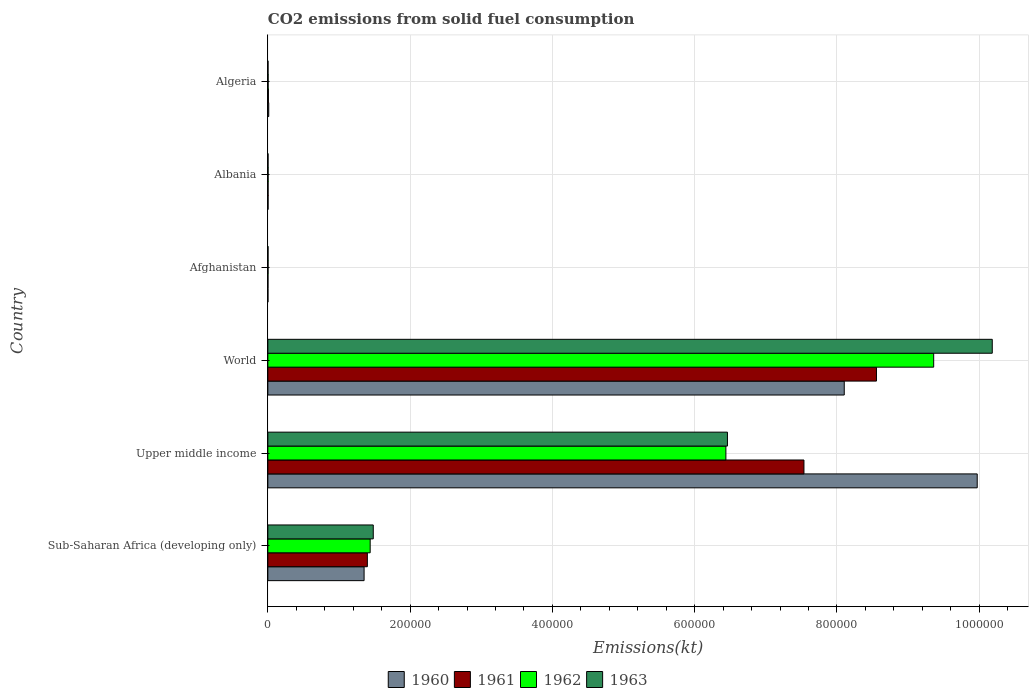How many bars are there on the 5th tick from the bottom?
Provide a succinct answer. 4. What is the label of the 3rd group of bars from the top?
Give a very brief answer. Afghanistan. In how many cases, is the number of bars for a given country not equal to the number of legend labels?
Your response must be concise. 0. What is the amount of CO2 emitted in 1963 in World?
Keep it short and to the point. 1.02e+06. Across all countries, what is the maximum amount of CO2 emitted in 1960?
Your response must be concise. 9.97e+05. Across all countries, what is the minimum amount of CO2 emitted in 1963?
Keep it short and to the point. 253.02. In which country was the amount of CO2 emitted in 1963 maximum?
Provide a succinct answer. World. In which country was the amount of CO2 emitted in 1963 minimum?
Provide a succinct answer. Algeria. What is the total amount of CO2 emitted in 1960 in the graph?
Ensure brevity in your answer.  1.94e+06. What is the difference between the amount of CO2 emitted in 1963 in Albania and that in Sub-Saharan Africa (developing only)?
Give a very brief answer. -1.48e+05. What is the difference between the amount of CO2 emitted in 1962 in World and the amount of CO2 emitted in 1961 in Upper middle income?
Keep it short and to the point. 1.82e+05. What is the average amount of CO2 emitted in 1963 per country?
Provide a short and direct response. 3.02e+05. What is the difference between the amount of CO2 emitted in 1962 and amount of CO2 emitted in 1960 in Albania?
Give a very brief answer. 36.67. In how many countries, is the amount of CO2 emitted in 1962 greater than 720000 kt?
Provide a succinct answer. 1. What is the ratio of the amount of CO2 emitted in 1960 in Sub-Saharan Africa (developing only) to that in World?
Your answer should be compact. 0.17. Is the difference between the amount of CO2 emitted in 1962 in Afghanistan and Albania greater than the difference between the amount of CO2 emitted in 1960 in Afghanistan and Albania?
Offer a very short reply. Yes. What is the difference between the highest and the second highest amount of CO2 emitted in 1960?
Make the answer very short. 1.87e+05. What is the difference between the highest and the lowest amount of CO2 emitted in 1960?
Give a very brief answer. 9.97e+05. In how many countries, is the amount of CO2 emitted in 1963 greater than the average amount of CO2 emitted in 1963 taken over all countries?
Provide a short and direct response. 2. Is the sum of the amount of CO2 emitted in 1960 in Albania and World greater than the maximum amount of CO2 emitted in 1963 across all countries?
Ensure brevity in your answer.  No. What is the difference between two consecutive major ticks on the X-axis?
Offer a very short reply. 2.00e+05. Are the values on the major ticks of X-axis written in scientific E-notation?
Offer a terse response. No. Does the graph contain any zero values?
Offer a very short reply. No. Does the graph contain grids?
Your answer should be very brief. Yes. How are the legend labels stacked?
Provide a succinct answer. Horizontal. What is the title of the graph?
Offer a very short reply. CO2 emissions from solid fuel consumption. Does "1969" appear as one of the legend labels in the graph?
Keep it short and to the point. No. What is the label or title of the X-axis?
Ensure brevity in your answer.  Emissions(kt). What is the label or title of the Y-axis?
Your response must be concise. Country. What is the Emissions(kt) in 1960 in Sub-Saharan Africa (developing only)?
Provide a succinct answer. 1.35e+05. What is the Emissions(kt) in 1961 in Sub-Saharan Africa (developing only)?
Provide a short and direct response. 1.40e+05. What is the Emissions(kt) of 1962 in Sub-Saharan Africa (developing only)?
Give a very brief answer. 1.44e+05. What is the Emissions(kt) of 1963 in Sub-Saharan Africa (developing only)?
Provide a succinct answer. 1.48e+05. What is the Emissions(kt) of 1960 in Upper middle income?
Your response must be concise. 9.97e+05. What is the Emissions(kt) in 1961 in Upper middle income?
Your answer should be very brief. 7.54e+05. What is the Emissions(kt) in 1962 in Upper middle income?
Give a very brief answer. 6.44e+05. What is the Emissions(kt) in 1963 in Upper middle income?
Offer a terse response. 6.46e+05. What is the Emissions(kt) of 1960 in World?
Your response must be concise. 8.10e+05. What is the Emissions(kt) of 1961 in World?
Your answer should be very brief. 8.56e+05. What is the Emissions(kt) of 1962 in World?
Your response must be concise. 9.36e+05. What is the Emissions(kt) of 1963 in World?
Give a very brief answer. 1.02e+06. What is the Emissions(kt) in 1960 in Afghanistan?
Offer a very short reply. 128.34. What is the Emissions(kt) in 1961 in Afghanistan?
Provide a short and direct response. 176.02. What is the Emissions(kt) of 1962 in Afghanistan?
Make the answer very short. 297.03. What is the Emissions(kt) of 1963 in Afghanistan?
Keep it short and to the point. 264.02. What is the Emissions(kt) of 1960 in Albania?
Provide a succinct answer. 326.36. What is the Emissions(kt) of 1961 in Albania?
Your answer should be compact. 322.7. What is the Emissions(kt) in 1962 in Albania?
Make the answer very short. 363.03. What is the Emissions(kt) in 1963 in Albania?
Provide a short and direct response. 282.36. What is the Emissions(kt) in 1960 in Algeria?
Keep it short and to the point. 1257.78. What is the Emissions(kt) in 1961 in Algeria?
Offer a very short reply. 766.4. What is the Emissions(kt) of 1962 in Algeria?
Keep it short and to the point. 407.04. What is the Emissions(kt) in 1963 in Algeria?
Offer a terse response. 253.02. Across all countries, what is the maximum Emissions(kt) in 1960?
Make the answer very short. 9.97e+05. Across all countries, what is the maximum Emissions(kt) in 1961?
Offer a terse response. 8.56e+05. Across all countries, what is the maximum Emissions(kt) of 1962?
Your answer should be very brief. 9.36e+05. Across all countries, what is the maximum Emissions(kt) in 1963?
Give a very brief answer. 1.02e+06. Across all countries, what is the minimum Emissions(kt) of 1960?
Offer a terse response. 128.34. Across all countries, what is the minimum Emissions(kt) in 1961?
Your answer should be compact. 176.02. Across all countries, what is the minimum Emissions(kt) of 1962?
Make the answer very short. 297.03. Across all countries, what is the minimum Emissions(kt) in 1963?
Your response must be concise. 253.02. What is the total Emissions(kt) in 1960 in the graph?
Make the answer very short. 1.94e+06. What is the total Emissions(kt) in 1961 in the graph?
Give a very brief answer. 1.75e+06. What is the total Emissions(kt) of 1962 in the graph?
Offer a terse response. 1.72e+06. What is the total Emissions(kt) of 1963 in the graph?
Keep it short and to the point. 1.81e+06. What is the difference between the Emissions(kt) in 1960 in Sub-Saharan Africa (developing only) and that in Upper middle income?
Your response must be concise. -8.62e+05. What is the difference between the Emissions(kt) in 1961 in Sub-Saharan Africa (developing only) and that in Upper middle income?
Your answer should be very brief. -6.14e+05. What is the difference between the Emissions(kt) in 1962 in Sub-Saharan Africa (developing only) and that in Upper middle income?
Give a very brief answer. -5.00e+05. What is the difference between the Emissions(kt) in 1963 in Sub-Saharan Africa (developing only) and that in Upper middle income?
Keep it short and to the point. -4.98e+05. What is the difference between the Emissions(kt) of 1960 in Sub-Saharan Africa (developing only) and that in World?
Give a very brief answer. -6.75e+05. What is the difference between the Emissions(kt) of 1961 in Sub-Saharan Africa (developing only) and that in World?
Offer a very short reply. -7.16e+05. What is the difference between the Emissions(kt) in 1962 in Sub-Saharan Africa (developing only) and that in World?
Give a very brief answer. -7.92e+05. What is the difference between the Emissions(kt) of 1963 in Sub-Saharan Africa (developing only) and that in World?
Give a very brief answer. -8.70e+05. What is the difference between the Emissions(kt) of 1960 in Sub-Saharan Africa (developing only) and that in Afghanistan?
Give a very brief answer. 1.35e+05. What is the difference between the Emissions(kt) of 1961 in Sub-Saharan Africa (developing only) and that in Afghanistan?
Your answer should be compact. 1.40e+05. What is the difference between the Emissions(kt) in 1962 in Sub-Saharan Africa (developing only) and that in Afghanistan?
Give a very brief answer. 1.44e+05. What is the difference between the Emissions(kt) of 1963 in Sub-Saharan Africa (developing only) and that in Afghanistan?
Your response must be concise. 1.48e+05. What is the difference between the Emissions(kt) in 1960 in Sub-Saharan Africa (developing only) and that in Albania?
Give a very brief answer. 1.35e+05. What is the difference between the Emissions(kt) of 1961 in Sub-Saharan Africa (developing only) and that in Albania?
Offer a very short reply. 1.40e+05. What is the difference between the Emissions(kt) in 1962 in Sub-Saharan Africa (developing only) and that in Albania?
Offer a very short reply. 1.43e+05. What is the difference between the Emissions(kt) of 1963 in Sub-Saharan Africa (developing only) and that in Albania?
Offer a terse response. 1.48e+05. What is the difference between the Emissions(kt) in 1960 in Sub-Saharan Africa (developing only) and that in Algeria?
Offer a terse response. 1.34e+05. What is the difference between the Emissions(kt) of 1961 in Sub-Saharan Africa (developing only) and that in Algeria?
Your answer should be very brief. 1.39e+05. What is the difference between the Emissions(kt) in 1962 in Sub-Saharan Africa (developing only) and that in Algeria?
Ensure brevity in your answer.  1.43e+05. What is the difference between the Emissions(kt) in 1963 in Sub-Saharan Africa (developing only) and that in Algeria?
Ensure brevity in your answer.  1.48e+05. What is the difference between the Emissions(kt) of 1960 in Upper middle income and that in World?
Give a very brief answer. 1.87e+05. What is the difference between the Emissions(kt) of 1961 in Upper middle income and that in World?
Your answer should be compact. -1.02e+05. What is the difference between the Emissions(kt) of 1962 in Upper middle income and that in World?
Make the answer very short. -2.92e+05. What is the difference between the Emissions(kt) in 1963 in Upper middle income and that in World?
Provide a short and direct response. -3.72e+05. What is the difference between the Emissions(kt) of 1960 in Upper middle income and that in Afghanistan?
Make the answer very short. 9.97e+05. What is the difference between the Emissions(kt) in 1961 in Upper middle income and that in Afghanistan?
Your answer should be very brief. 7.53e+05. What is the difference between the Emissions(kt) of 1962 in Upper middle income and that in Afghanistan?
Make the answer very short. 6.44e+05. What is the difference between the Emissions(kt) in 1963 in Upper middle income and that in Afghanistan?
Offer a terse response. 6.46e+05. What is the difference between the Emissions(kt) of 1960 in Upper middle income and that in Albania?
Ensure brevity in your answer.  9.97e+05. What is the difference between the Emissions(kt) in 1961 in Upper middle income and that in Albania?
Offer a terse response. 7.53e+05. What is the difference between the Emissions(kt) of 1962 in Upper middle income and that in Albania?
Offer a terse response. 6.44e+05. What is the difference between the Emissions(kt) in 1963 in Upper middle income and that in Albania?
Ensure brevity in your answer.  6.46e+05. What is the difference between the Emissions(kt) of 1960 in Upper middle income and that in Algeria?
Provide a short and direct response. 9.96e+05. What is the difference between the Emissions(kt) of 1961 in Upper middle income and that in Algeria?
Provide a succinct answer. 7.53e+05. What is the difference between the Emissions(kt) of 1962 in Upper middle income and that in Algeria?
Offer a very short reply. 6.44e+05. What is the difference between the Emissions(kt) in 1963 in Upper middle income and that in Algeria?
Give a very brief answer. 6.46e+05. What is the difference between the Emissions(kt) in 1960 in World and that in Afghanistan?
Your answer should be compact. 8.10e+05. What is the difference between the Emissions(kt) of 1961 in World and that in Afghanistan?
Give a very brief answer. 8.55e+05. What is the difference between the Emissions(kt) in 1962 in World and that in Afghanistan?
Give a very brief answer. 9.36e+05. What is the difference between the Emissions(kt) of 1963 in World and that in Afghanistan?
Provide a succinct answer. 1.02e+06. What is the difference between the Emissions(kt) in 1960 in World and that in Albania?
Give a very brief answer. 8.10e+05. What is the difference between the Emissions(kt) in 1961 in World and that in Albania?
Keep it short and to the point. 8.55e+05. What is the difference between the Emissions(kt) in 1962 in World and that in Albania?
Give a very brief answer. 9.36e+05. What is the difference between the Emissions(kt) in 1963 in World and that in Albania?
Offer a terse response. 1.02e+06. What is the difference between the Emissions(kt) of 1960 in World and that in Algeria?
Provide a succinct answer. 8.09e+05. What is the difference between the Emissions(kt) of 1961 in World and that in Algeria?
Your answer should be compact. 8.55e+05. What is the difference between the Emissions(kt) of 1962 in World and that in Algeria?
Provide a succinct answer. 9.36e+05. What is the difference between the Emissions(kt) of 1963 in World and that in Algeria?
Provide a short and direct response. 1.02e+06. What is the difference between the Emissions(kt) of 1960 in Afghanistan and that in Albania?
Give a very brief answer. -198.02. What is the difference between the Emissions(kt) of 1961 in Afghanistan and that in Albania?
Keep it short and to the point. -146.68. What is the difference between the Emissions(kt) in 1962 in Afghanistan and that in Albania?
Provide a short and direct response. -66.01. What is the difference between the Emissions(kt) of 1963 in Afghanistan and that in Albania?
Keep it short and to the point. -18.34. What is the difference between the Emissions(kt) of 1960 in Afghanistan and that in Algeria?
Provide a succinct answer. -1129.44. What is the difference between the Emissions(kt) in 1961 in Afghanistan and that in Algeria?
Make the answer very short. -590.39. What is the difference between the Emissions(kt) in 1962 in Afghanistan and that in Algeria?
Your answer should be compact. -110.01. What is the difference between the Emissions(kt) in 1963 in Afghanistan and that in Algeria?
Give a very brief answer. 11. What is the difference between the Emissions(kt) in 1960 in Albania and that in Algeria?
Your response must be concise. -931.42. What is the difference between the Emissions(kt) of 1961 in Albania and that in Algeria?
Offer a terse response. -443.71. What is the difference between the Emissions(kt) of 1962 in Albania and that in Algeria?
Offer a very short reply. -44. What is the difference between the Emissions(kt) of 1963 in Albania and that in Algeria?
Provide a succinct answer. 29.34. What is the difference between the Emissions(kt) of 1960 in Sub-Saharan Africa (developing only) and the Emissions(kt) of 1961 in Upper middle income?
Provide a short and direct response. -6.18e+05. What is the difference between the Emissions(kt) in 1960 in Sub-Saharan Africa (developing only) and the Emissions(kt) in 1962 in Upper middle income?
Make the answer very short. -5.09e+05. What is the difference between the Emissions(kt) in 1960 in Sub-Saharan Africa (developing only) and the Emissions(kt) in 1963 in Upper middle income?
Offer a terse response. -5.11e+05. What is the difference between the Emissions(kt) of 1961 in Sub-Saharan Africa (developing only) and the Emissions(kt) of 1962 in Upper middle income?
Make the answer very short. -5.04e+05. What is the difference between the Emissions(kt) of 1961 in Sub-Saharan Africa (developing only) and the Emissions(kt) of 1963 in Upper middle income?
Your response must be concise. -5.06e+05. What is the difference between the Emissions(kt) of 1962 in Sub-Saharan Africa (developing only) and the Emissions(kt) of 1963 in Upper middle income?
Your answer should be compact. -5.02e+05. What is the difference between the Emissions(kt) in 1960 in Sub-Saharan Africa (developing only) and the Emissions(kt) in 1961 in World?
Ensure brevity in your answer.  -7.20e+05. What is the difference between the Emissions(kt) in 1960 in Sub-Saharan Africa (developing only) and the Emissions(kt) in 1962 in World?
Give a very brief answer. -8.01e+05. What is the difference between the Emissions(kt) of 1960 in Sub-Saharan Africa (developing only) and the Emissions(kt) of 1963 in World?
Your answer should be compact. -8.83e+05. What is the difference between the Emissions(kt) of 1961 in Sub-Saharan Africa (developing only) and the Emissions(kt) of 1962 in World?
Your answer should be very brief. -7.96e+05. What is the difference between the Emissions(kt) of 1961 in Sub-Saharan Africa (developing only) and the Emissions(kt) of 1963 in World?
Keep it short and to the point. -8.79e+05. What is the difference between the Emissions(kt) of 1962 in Sub-Saharan Africa (developing only) and the Emissions(kt) of 1963 in World?
Your answer should be very brief. -8.75e+05. What is the difference between the Emissions(kt) of 1960 in Sub-Saharan Africa (developing only) and the Emissions(kt) of 1961 in Afghanistan?
Offer a terse response. 1.35e+05. What is the difference between the Emissions(kt) in 1960 in Sub-Saharan Africa (developing only) and the Emissions(kt) in 1962 in Afghanistan?
Offer a very short reply. 1.35e+05. What is the difference between the Emissions(kt) in 1960 in Sub-Saharan Africa (developing only) and the Emissions(kt) in 1963 in Afghanistan?
Give a very brief answer. 1.35e+05. What is the difference between the Emissions(kt) in 1961 in Sub-Saharan Africa (developing only) and the Emissions(kt) in 1962 in Afghanistan?
Keep it short and to the point. 1.40e+05. What is the difference between the Emissions(kt) of 1961 in Sub-Saharan Africa (developing only) and the Emissions(kt) of 1963 in Afghanistan?
Keep it short and to the point. 1.40e+05. What is the difference between the Emissions(kt) of 1962 in Sub-Saharan Africa (developing only) and the Emissions(kt) of 1963 in Afghanistan?
Provide a succinct answer. 1.44e+05. What is the difference between the Emissions(kt) of 1960 in Sub-Saharan Africa (developing only) and the Emissions(kt) of 1961 in Albania?
Offer a very short reply. 1.35e+05. What is the difference between the Emissions(kt) in 1960 in Sub-Saharan Africa (developing only) and the Emissions(kt) in 1962 in Albania?
Offer a very short reply. 1.35e+05. What is the difference between the Emissions(kt) of 1960 in Sub-Saharan Africa (developing only) and the Emissions(kt) of 1963 in Albania?
Give a very brief answer. 1.35e+05. What is the difference between the Emissions(kt) in 1961 in Sub-Saharan Africa (developing only) and the Emissions(kt) in 1962 in Albania?
Ensure brevity in your answer.  1.40e+05. What is the difference between the Emissions(kt) in 1961 in Sub-Saharan Africa (developing only) and the Emissions(kt) in 1963 in Albania?
Make the answer very short. 1.40e+05. What is the difference between the Emissions(kt) of 1962 in Sub-Saharan Africa (developing only) and the Emissions(kt) of 1963 in Albania?
Your answer should be compact. 1.44e+05. What is the difference between the Emissions(kt) in 1960 in Sub-Saharan Africa (developing only) and the Emissions(kt) in 1961 in Algeria?
Offer a very short reply. 1.35e+05. What is the difference between the Emissions(kt) of 1960 in Sub-Saharan Africa (developing only) and the Emissions(kt) of 1962 in Algeria?
Ensure brevity in your answer.  1.35e+05. What is the difference between the Emissions(kt) of 1960 in Sub-Saharan Africa (developing only) and the Emissions(kt) of 1963 in Algeria?
Your answer should be compact. 1.35e+05. What is the difference between the Emissions(kt) in 1961 in Sub-Saharan Africa (developing only) and the Emissions(kt) in 1962 in Algeria?
Your answer should be compact. 1.39e+05. What is the difference between the Emissions(kt) of 1961 in Sub-Saharan Africa (developing only) and the Emissions(kt) of 1963 in Algeria?
Provide a short and direct response. 1.40e+05. What is the difference between the Emissions(kt) of 1962 in Sub-Saharan Africa (developing only) and the Emissions(kt) of 1963 in Algeria?
Ensure brevity in your answer.  1.44e+05. What is the difference between the Emissions(kt) of 1960 in Upper middle income and the Emissions(kt) of 1961 in World?
Provide a short and direct response. 1.42e+05. What is the difference between the Emissions(kt) in 1960 in Upper middle income and the Emissions(kt) in 1962 in World?
Give a very brief answer. 6.12e+04. What is the difference between the Emissions(kt) of 1960 in Upper middle income and the Emissions(kt) of 1963 in World?
Give a very brief answer. -2.12e+04. What is the difference between the Emissions(kt) in 1961 in Upper middle income and the Emissions(kt) in 1962 in World?
Your response must be concise. -1.82e+05. What is the difference between the Emissions(kt) in 1961 in Upper middle income and the Emissions(kt) in 1963 in World?
Your response must be concise. -2.65e+05. What is the difference between the Emissions(kt) of 1962 in Upper middle income and the Emissions(kt) of 1963 in World?
Your answer should be compact. -3.74e+05. What is the difference between the Emissions(kt) in 1960 in Upper middle income and the Emissions(kt) in 1961 in Afghanistan?
Ensure brevity in your answer.  9.97e+05. What is the difference between the Emissions(kt) of 1960 in Upper middle income and the Emissions(kt) of 1962 in Afghanistan?
Your answer should be very brief. 9.97e+05. What is the difference between the Emissions(kt) of 1960 in Upper middle income and the Emissions(kt) of 1963 in Afghanistan?
Your answer should be very brief. 9.97e+05. What is the difference between the Emissions(kt) of 1961 in Upper middle income and the Emissions(kt) of 1962 in Afghanistan?
Provide a short and direct response. 7.53e+05. What is the difference between the Emissions(kt) in 1961 in Upper middle income and the Emissions(kt) in 1963 in Afghanistan?
Your answer should be compact. 7.53e+05. What is the difference between the Emissions(kt) in 1962 in Upper middle income and the Emissions(kt) in 1963 in Afghanistan?
Make the answer very short. 6.44e+05. What is the difference between the Emissions(kt) in 1960 in Upper middle income and the Emissions(kt) in 1961 in Albania?
Your response must be concise. 9.97e+05. What is the difference between the Emissions(kt) in 1960 in Upper middle income and the Emissions(kt) in 1962 in Albania?
Keep it short and to the point. 9.97e+05. What is the difference between the Emissions(kt) of 1960 in Upper middle income and the Emissions(kt) of 1963 in Albania?
Give a very brief answer. 9.97e+05. What is the difference between the Emissions(kt) in 1961 in Upper middle income and the Emissions(kt) in 1962 in Albania?
Offer a very short reply. 7.53e+05. What is the difference between the Emissions(kt) in 1961 in Upper middle income and the Emissions(kt) in 1963 in Albania?
Provide a succinct answer. 7.53e+05. What is the difference between the Emissions(kt) in 1962 in Upper middle income and the Emissions(kt) in 1963 in Albania?
Ensure brevity in your answer.  6.44e+05. What is the difference between the Emissions(kt) in 1960 in Upper middle income and the Emissions(kt) in 1961 in Algeria?
Ensure brevity in your answer.  9.97e+05. What is the difference between the Emissions(kt) of 1960 in Upper middle income and the Emissions(kt) of 1962 in Algeria?
Provide a succinct answer. 9.97e+05. What is the difference between the Emissions(kt) of 1960 in Upper middle income and the Emissions(kt) of 1963 in Algeria?
Your answer should be compact. 9.97e+05. What is the difference between the Emissions(kt) in 1961 in Upper middle income and the Emissions(kt) in 1962 in Algeria?
Offer a very short reply. 7.53e+05. What is the difference between the Emissions(kt) of 1961 in Upper middle income and the Emissions(kt) of 1963 in Algeria?
Keep it short and to the point. 7.53e+05. What is the difference between the Emissions(kt) of 1962 in Upper middle income and the Emissions(kt) of 1963 in Algeria?
Your answer should be very brief. 6.44e+05. What is the difference between the Emissions(kt) of 1960 in World and the Emissions(kt) of 1961 in Afghanistan?
Offer a terse response. 8.10e+05. What is the difference between the Emissions(kt) of 1960 in World and the Emissions(kt) of 1962 in Afghanistan?
Your answer should be compact. 8.10e+05. What is the difference between the Emissions(kt) in 1960 in World and the Emissions(kt) in 1963 in Afghanistan?
Your answer should be compact. 8.10e+05. What is the difference between the Emissions(kt) in 1961 in World and the Emissions(kt) in 1962 in Afghanistan?
Make the answer very short. 8.55e+05. What is the difference between the Emissions(kt) of 1961 in World and the Emissions(kt) of 1963 in Afghanistan?
Keep it short and to the point. 8.55e+05. What is the difference between the Emissions(kt) in 1962 in World and the Emissions(kt) in 1963 in Afghanistan?
Offer a terse response. 9.36e+05. What is the difference between the Emissions(kt) in 1960 in World and the Emissions(kt) in 1961 in Albania?
Offer a very short reply. 8.10e+05. What is the difference between the Emissions(kt) of 1960 in World and the Emissions(kt) of 1962 in Albania?
Ensure brevity in your answer.  8.10e+05. What is the difference between the Emissions(kt) in 1960 in World and the Emissions(kt) in 1963 in Albania?
Keep it short and to the point. 8.10e+05. What is the difference between the Emissions(kt) of 1961 in World and the Emissions(kt) of 1962 in Albania?
Ensure brevity in your answer.  8.55e+05. What is the difference between the Emissions(kt) in 1961 in World and the Emissions(kt) in 1963 in Albania?
Give a very brief answer. 8.55e+05. What is the difference between the Emissions(kt) of 1962 in World and the Emissions(kt) of 1963 in Albania?
Keep it short and to the point. 9.36e+05. What is the difference between the Emissions(kt) of 1960 in World and the Emissions(kt) of 1961 in Algeria?
Offer a terse response. 8.10e+05. What is the difference between the Emissions(kt) of 1960 in World and the Emissions(kt) of 1962 in Algeria?
Keep it short and to the point. 8.10e+05. What is the difference between the Emissions(kt) in 1960 in World and the Emissions(kt) in 1963 in Algeria?
Make the answer very short. 8.10e+05. What is the difference between the Emissions(kt) of 1961 in World and the Emissions(kt) of 1962 in Algeria?
Make the answer very short. 8.55e+05. What is the difference between the Emissions(kt) of 1961 in World and the Emissions(kt) of 1963 in Algeria?
Your answer should be very brief. 8.55e+05. What is the difference between the Emissions(kt) of 1962 in World and the Emissions(kt) of 1963 in Algeria?
Make the answer very short. 9.36e+05. What is the difference between the Emissions(kt) of 1960 in Afghanistan and the Emissions(kt) of 1961 in Albania?
Your answer should be very brief. -194.35. What is the difference between the Emissions(kt) of 1960 in Afghanistan and the Emissions(kt) of 1962 in Albania?
Your response must be concise. -234.69. What is the difference between the Emissions(kt) in 1960 in Afghanistan and the Emissions(kt) in 1963 in Albania?
Make the answer very short. -154.01. What is the difference between the Emissions(kt) in 1961 in Afghanistan and the Emissions(kt) in 1962 in Albania?
Ensure brevity in your answer.  -187.02. What is the difference between the Emissions(kt) in 1961 in Afghanistan and the Emissions(kt) in 1963 in Albania?
Ensure brevity in your answer.  -106.34. What is the difference between the Emissions(kt) in 1962 in Afghanistan and the Emissions(kt) in 1963 in Albania?
Your answer should be compact. 14.67. What is the difference between the Emissions(kt) of 1960 in Afghanistan and the Emissions(kt) of 1961 in Algeria?
Offer a terse response. -638.06. What is the difference between the Emissions(kt) of 1960 in Afghanistan and the Emissions(kt) of 1962 in Algeria?
Your answer should be compact. -278.69. What is the difference between the Emissions(kt) in 1960 in Afghanistan and the Emissions(kt) in 1963 in Algeria?
Your answer should be compact. -124.68. What is the difference between the Emissions(kt) in 1961 in Afghanistan and the Emissions(kt) in 1962 in Algeria?
Keep it short and to the point. -231.02. What is the difference between the Emissions(kt) in 1961 in Afghanistan and the Emissions(kt) in 1963 in Algeria?
Make the answer very short. -77.01. What is the difference between the Emissions(kt) of 1962 in Afghanistan and the Emissions(kt) of 1963 in Algeria?
Keep it short and to the point. 44. What is the difference between the Emissions(kt) of 1960 in Albania and the Emissions(kt) of 1961 in Algeria?
Offer a very short reply. -440.04. What is the difference between the Emissions(kt) in 1960 in Albania and the Emissions(kt) in 1962 in Algeria?
Offer a terse response. -80.67. What is the difference between the Emissions(kt) in 1960 in Albania and the Emissions(kt) in 1963 in Algeria?
Offer a very short reply. 73.34. What is the difference between the Emissions(kt) in 1961 in Albania and the Emissions(kt) in 1962 in Algeria?
Offer a terse response. -84.34. What is the difference between the Emissions(kt) of 1961 in Albania and the Emissions(kt) of 1963 in Algeria?
Provide a succinct answer. 69.67. What is the difference between the Emissions(kt) of 1962 in Albania and the Emissions(kt) of 1963 in Algeria?
Your response must be concise. 110.01. What is the average Emissions(kt) of 1960 per country?
Offer a very short reply. 3.24e+05. What is the average Emissions(kt) of 1961 per country?
Offer a very short reply. 2.92e+05. What is the average Emissions(kt) in 1962 per country?
Provide a short and direct response. 2.87e+05. What is the average Emissions(kt) of 1963 per country?
Make the answer very short. 3.02e+05. What is the difference between the Emissions(kt) of 1960 and Emissions(kt) of 1961 in Sub-Saharan Africa (developing only)?
Your answer should be very brief. -4582.5. What is the difference between the Emissions(kt) of 1960 and Emissions(kt) of 1962 in Sub-Saharan Africa (developing only)?
Make the answer very short. -8539.18. What is the difference between the Emissions(kt) in 1960 and Emissions(kt) in 1963 in Sub-Saharan Africa (developing only)?
Offer a terse response. -1.29e+04. What is the difference between the Emissions(kt) of 1961 and Emissions(kt) of 1962 in Sub-Saharan Africa (developing only)?
Provide a succinct answer. -3956.69. What is the difference between the Emissions(kt) in 1961 and Emissions(kt) in 1963 in Sub-Saharan Africa (developing only)?
Offer a very short reply. -8302.03. What is the difference between the Emissions(kt) in 1962 and Emissions(kt) in 1963 in Sub-Saharan Africa (developing only)?
Offer a very short reply. -4345.34. What is the difference between the Emissions(kt) in 1960 and Emissions(kt) in 1961 in Upper middle income?
Provide a succinct answer. 2.44e+05. What is the difference between the Emissions(kt) in 1960 and Emissions(kt) in 1962 in Upper middle income?
Offer a very short reply. 3.53e+05. What is the difference between the Emissions(kt) of 1960 and Emissions(kt) of 1963 in Upper middle income?
Give a very brief answer. 3.51e+05. What is the difference between the Emissions(kt) in 1961 and Emissions(kt) in 1962 in Upper middle income?
Provide a short and direct response. 1.10e+05. What is the difference between the Emissions(kt) of 1961 and Emissions(kt) of 1963 in Upper middle income?
Your answer should be compact. 1.08e+05. What is the difference between the Emissions(kt) of 1962 and Emissions(kt) of 1963 in Upper middle income?
Ensure brevity in your answer.  -2192.22. What is the difference between the Emissions(kt) of 1960 and Emissions(kt) of 1961 in World?
Offer a terse response. -4.53e+04. What is the difference between the Emissions(kt) of 1960 and Emissions(kt) of 1962 in World?
Your response must be concise. -1.26e+05. What is the difference between the Emissions(kt) in 1960 and Emissions(kt) in 1963 in World?
Make the answer very short. -2.08e+05. What is the difference between the Emissions(kt) of 1961 and Emissions(kt) of 1962 in World?
Make the answer very short. -8.05e+04. What is the difference between the Emissions(kt) of 1961 and Emissions(kt) of 1963 in World?
Offer a very short reply. -1.63e+05. What is the difference between the Emissions(kt) in 1962 and Emissions(kt) in 1963 in World?
Ensure brevity in your answer.  -8.24e+04. What is the difference between the Emissions(kt) of 1960 and Emissions(kt) of 1961 in Afghanistan?
Keep it short and to the point. -47.67. What is the difference between the Emissions(kt) of 1960 and Emissions(kt) of 1962 in Afghanistan?
Keep it short and to the point. -168.68. What is the difference between the Emissions(kt) in 1960 and Emissions(kt) in 1963 in Afghanistan?
Make the answer very short. -135.68. What is the difference between the Emissions(kt) of 1961 and Emissions(kt) of 1962 in Afghanistan?
Your answer should be very brief. -121.01. What is the difference between the Emissions(kt) in 1961 and Emissions(kt) in 1963 in Afghanistan?
Offer a terse response. -88.01. What is the difference between the Emissions(kt) in 1962 and Emissions(kt) in 1963 in Afghanistan?
Provide a short and direct response. 33. What is the difference between the Emissions(kt) in 1960 and Emissions(kt) in 1961 in Albania?
Provide a short and direct response. 3.67. What is the difference between the Emissions(kt) in 1960 and Emissions(kt) in 1962 in Albania?
Offer a terse response. -36.67. What is the difference between the Emissions(kt) of 1960 and Emissions(kt) of 1963 in Albania?
Keep it short and to the point. 44. What is the difference between the Emissions(kt) in 1961 and Emissions(kt) in 1962 in Albania?
Ensure brevity in your answer.  -40.34. What is the difference between the Emissions(kt) in 1961 and Emissions(kt) in 1963 in Albania?
Give a very brief answer. 40.34. What is the difference between the Emissions(kt) in 1962 and Emissions(kt) in 1963 in Albania?
Give a very brief answer. 80.67. What is the difference between the Emissions(kt) of 1960 and Emissions(kt) of 1961 in Algeria?
Provide a short and direct response. 491.38. What is the difference between the Emissions(kt) of 1960 and Emissions(kt) of 1962 in Algeria?
Offer a very short reply. 850.74. What is the difference between the Emissions(kt) in 1960 and Emissions(kt) in 1963 in Algeria?
Provide a short and direct response. 1004.76. What is the difference between the Emissions(kt) in 1961 and Emissions(kt) in 1962 in Algeria?
Provide a succinct answer. 359.37. What is the difference between the Emissions(kt) of 1961 and Emissions(kt) of 1963 in Algeria?
Provide a succinct answer. 513.38. What is the difference between the Emissions(kt) in 1962 and Emissions(kt) in 1963 in Algeria?
Your response must be concise. 154.01. What is the ratio of the Emissions(kt) of 1960 in Sub-Saharan Africa (developing only) to that in Upper middle income?
Your answer should be very brief. 0.14. What is the ratio of the Emissions(kt) in 1961 in Sub-Saharan Africa (developing only) to that in Upper middle income?
Your answer should be very brief. 0.19. What is the ratio of the Emissions(kt) in 1962 in Sub-Saharan Africa (developing only) to that in Upper middle income?
Offer a very short reply. 0.22. What is the ratio of the Emissions(kt) in 1963 in Sub-Saharan Africa (developing only) to that in Upper middle income?
Your answer should be compact. 0.23. What is the ratio of the Emissions(kt) of 1960 in Sub-Saharan Africa (developing only) to that in World?
Your answer should be compact. 0.17. What is the ratio of the Emissions(kt) in 1961 in Sub-Saharan Africa (developing only) to that in World?
Offer a very short reply. 0.16. What is the ratio of the Emissions(kt) in 1962 in Sub-Saharan Africa (developing only) to that in World?
Ensure brevity in your answer.  0.15. What is the ratio of the Emissions(kt) of 1963 in Sub-Saharan Africa (developing only) to that in World?
Provide a succinct answer. 0.15. What is the ratio of the Emissions(kt) of 1960 in Sub-Saharan Africa (developing only) to that in Afghanistan?
Your answer should be compact. 1054.27. What is the ratio of the Emissions(kt) in 1961 in Sub-Saharan Africa (developing only) to that in Afghanistan?
Give a very brief answer. 794.77. What is the ratio of the Emissions(kt) of 1962 in Sub-Saharan Africa (developing only) to that in Afghanistan?
Give a very brief answer. 484.3. What is the ratio of the Emissions(kt) in 1963 in Sub-Saharan Africa (developing only) to that in Afghanistan?
Ensure brevity in your answer.  561.29. What is the ratio of the Emissions(kt) of 1960 in Sub-Saharan Africa (developing only) to that in Albania?
Your answer should be very brief. 414.6. What is the ratio of the Emissions(kt) in 1961 in Sub-Saharan Africa (developing only) to that in Albania?
Provide a succinct answer. 433.51. What is the ratio of the Emissions(kt) in 1962 in Sub-Saharan Africa (developing only) to that in Albania?
Offer a terse response. 396.24. What is the ratio of the Emissions(kt) of 1963 in Sub-Saharan Africa (developing only) to that in Albania?
Make the answer very short. 524.85. What is the ratio of the Emissions(kt) of 1960 in Sub-Saharan Africa (developing only) to that in Algeria?
Provide a short and direct response. 107.58. What is the ratio of the Emissions(kt) of 1961 in Sub-Saharan Africa (developing only) to that in Algeria?
Offer a terse response. 182.53. What is the ratio of the Emissions(kt) in 1962 in Sub-Saharan Africa (developing only) to that in Algeria?
Ensure brevity in your answer.  353.41. What is the ratio of the Emissions(kt) of 1963 in Sub-Saharan Africa (developing only) to that in Algeria?
Offer a terse response. 585.7. What is the ratio of the Emissions(kt) of 1960 in Upper middle income to that in World?
Ensure brevity in your answer.  1.23. What is the ratio of the Emissions(kt) of 1961 in Upper middle income to that in World?
Your answer should be compact. 0.88. What is the ratio of the Emissions(kt) of 1962 in Upper middle income to that in World?
Make the answer very short. 0.69. What is the ratio of the Emissions(kt) in 1963 in Upper middle income to that in World?
Offer a very short reply. 0.63. What is the ratio of the Emissions(kt) of 1960 in Upper middle income to that in Afghanistan?
Offer a terse response. 7770.2. What is the ratio of the Emissions(kt) of 1961 in Upper middle income to that in Afghanistan?
Your response must be concise. 4281.81. What is the ratio of the Emissions(kt) of 1962 in Upper middle income to that in Afghanistan?
Ensure brevity in your answer.  2167.93. What is the ratio of the Emissions(kt) in 1963 in Upper middle income to that in Afghanistan?
Make the answer very short. 2447.22. What is the ratio of the Emissions(kt) in 1960 in Upper middle income to that in Albania?
Give a very brief answer. 3055.7. What is the ratio of the Emissions(kt) in 1961 in Upper middle income to that in Albania?
Make the answer very short. 2335.53. What is the ratio of the Emissions(kt) of 1962 in Upper middle income to that in Albania?
Your response must be concise. 1773.76. What is the ratio of the Emissions(kt) of 1963 in Upper middle income to that in Albania?
Provide a succinct answer. 2288.31. What is the ratio of the Emissions(kt) in 1960 in Upper middle income to that in Algeria?
Your response must be concise. 792.88. What is the ratio of the Emissions(kt) in 1961 in Upper middle income to that in Algeria?
Make the answer very short. 983.38. What is the ratio of the Emissions(kt) of 1962 in Upper middle income to that in Algeria?
Offer a very short reply. 1582. What is the ratio of the Emissions(kt) of 1963 in Upper middle income to that in Algeria?
Provide a short and direct response. 2553.62. What is the ratio of the Emissions(kt) in 1960 in World to that in Afghanistan?
Provide a succinct answer. 6313.69. What is the ratio of the Emissions(kt) in 1961 in World to that in Afghanistan?
Your response must be concise. 4860.98. What is the ratio of the Emissions(kt) of 1962 in World to that in Afghanistan?
Make the answer very short. 3151.44. What is the ratio of the Emissions(kt) in 1963 in World to that in Afghanistan?
Offer a very short reply. 3857.29. What is the ratio of the Emissions(kt) of 1960 in World to that in Albania?
Your response must be concise. 2482.91. What is the ratio of the Emissions(kt) in 1961 in World to that in Albania?
Provide a succinct answer. 2651.44. What is the ratio of the Emissions(kt) of 1962 in World to that in Albania?
Provide a succinct answer. 2578.45. What is the ratio of the Emissions(kt) of 1963 in World to that in Albania?
Offer a very short reply. 3606.82. What is the ratio of the Emissions(kt) in 1960 in World to that in Algeria?
Make the answer very short. 644.25. What is the ratio of the Emissions(kt) in 1961 in World to that in Algeria?
Make the answer very short. 1116.4. What is the ratio of the Emissions(kt) in 1962 in World to that in Algeria?
Provide a short and direct response. 2299.7. What is the ratio of the Emissions(kt) of 1963 in World to that in Algeria?
Your response must be concise. 4025. What is the ratio of the Emissions(kt) of 1960 in Afghanistan to that in Albania?
Keep it short and to the point. 0.39. What is the ratio of the Emissions(kt) in 1961 in Afghanistan to that in Albania?
Make the answer very short. 0.55. What is the ratio of the Emissions(kt) of 1962 in Afghanistan to that in Albania?
Your answer should be compact. 0.82. What is the ratio of the Emissions(kt) in 1963 in Afghanistan to that in Albania?
Provide a short and direct response. 0.94. What is the ratio of the Emissions(kt) of 1960 in Afghanistan to that in Algeria?
Your answer should be compact. 0.1. What is the ratio of the Emissions(kt) in 1961 in Afghanistan to that in Algeria?
Provide a succinct answer. 0.23. What is the ratio of the Emissions(kt) of 1962 in Afghanistan to that in Algeria?
Provide a short and direct response. 0.73. What is the ratio of the Emissions(kt) in 1963 in Afghanistan to that in Algeria?
Your answer should be very brief. 1.04. What is the ratio of the Emissions(kt) in 1960 in Albania to that in Algeria?
Provide a short and direct response. 0.26. What is the ratio of the Emissions(kt) of 1961 in Albania to that in Algeria?
Your answer should be very brief. 0.42. What is the ratio of the Emissions(kt) in 1962 in Albania to that in Algeria?
Your answer should be very brief. 0.89. What is the ratio of the Emissions(kt) of 1963 in Albania to that in Algeria?
Your answer should be very brief. 1.12. What is the difference between the highest and the second highest Emissions(kt) of 1960?
Ensure brevity in your answer.  1.87e+05. What is the difference between the highest and the second highest Emissions(kt) in 1961?
Your response must be concise. 1.02e+05. What is the difference between the highest and the second highest Emissions(kt) in 1962?
Offer a very short reply. 2.92e+05. What is the difference between the highest and the second highest Emissions(kt) in 1963?
Your response must be concise. 3.72e+05. What is the difference between the highest and the lowest Emissions(kt) of 1960?
Give a very brief answer. 9.97e+05. What is the difference between the highest and the lowest Emissions(kt) of 1961?
Make the answer very short. 8.55e+05. What is the difference between the highest and the lowest Emissions(kt) in 1962?
Your response must be concise. 9.36e+05. What is the difference between the highest and the lowest Emissions(kt) of 1963?
Your answer should be very brief. 1.02e+06. 